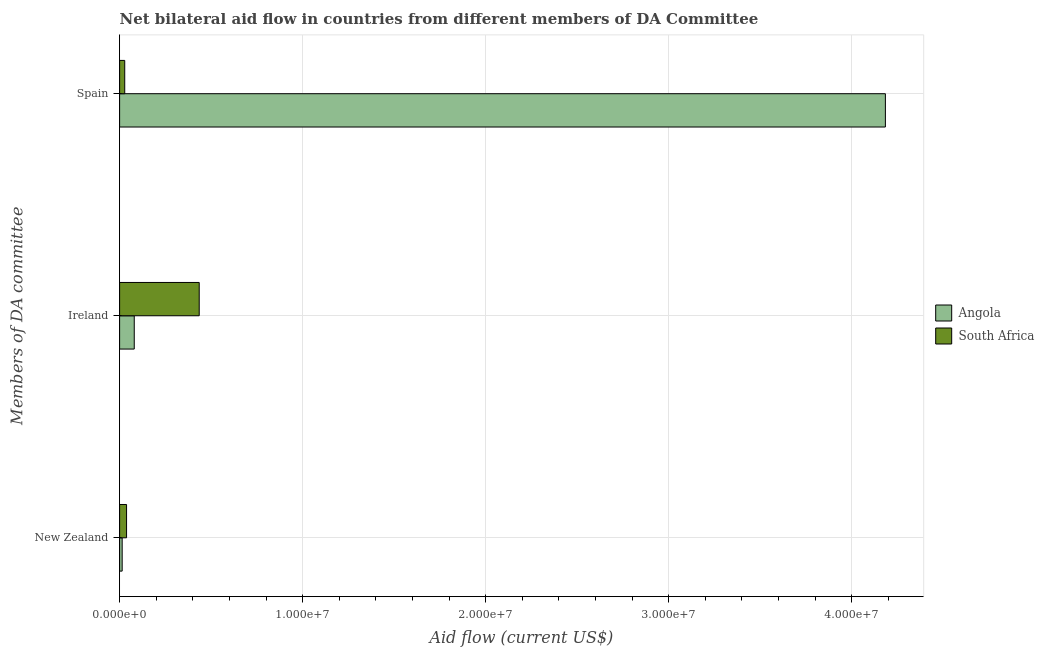How many different coloured bars are there?
Provide a short and direct response. 2. How many groups of bars are there?
Give a very brief answer. 3. Are the number of bars on each tick of the Y-axis equal?
Your response must be concise. Yes. How many bars are there on the 3rd tick from the top?
Provide a short and direct response. 2. What is the label of the 2nd group of bars from the top?
Give a very brief answer. Ireland. What is the amount of aid provided by spain in Angola?
Offer a very short reply. 4.18e+07. Across all countries, what is the maximum amount of aid provided by new zealand?
Offer a terse response. 3.80e+05. Across all countries, what is the minimum amount of aid provided by new zealand?
Keep it short and to the point. 1.40e+05. In which country was the amount of aid provided by ireland maximum?
Give a very brief answer. South Africa. In which country was the amount of aid provided by spain minimum?
Make the answer very short. South Africa. What is the total amount of aid provided by new zealand in the graph?
Make the answer very short. 5.20e+05. What is the difference between the amount of aid provided by spain in South Africa and that in Angola?
Offer a terse response. -4.16e+07. What is the difference between the amount of aid provided by spain in South Africa and the amount of aid provided by ireland in Angola?
Your answer should be compact. -5.20e+05. What is the average amount of aid provided by spain per country?
Your answer should be compact. 2.11e+07. What is the difference between the amount of aid provided by new zealand and amount of aid provided by spain in Angola?
Give a very brief answer. -4.17e+07. In how many countries, is the amount of aid provided by ireland greater than 2000000 US$?
Your answer should be very brief. 1. What is the ratio of the amount of aid provided by new zealand in South Africa to that in Angola?
Your answer should be compact. 2.71. Is the difference between the amount of aid provided by new zealand in Angola and South Africa greater than the difference between the amount of aid provided by ireland in Angola and South Africa?
Provide a succinct answer. Yes. What is the difference between the highest and the second highest amount of aid provided by spain?
Offer a terse response. 4.16e+07. What is the difference between the highest and the lowest amount of aid provided by spain?
Give a very brief answer. 4.16e+07. In how many countries, is the amount of aid provided by new zealand greater than the average amount of aid provided by new zealand taken over all countries?
Keep it short and to the point. 1. Is the sum of the amount of aid provided by ireland in South Africa and Angola greater than the maximum amount of aid provided by spain across all countries?
Give a very brief answer. No. What does the 1st bar from the top in Spain represents?
Provide a short and direct response. South Africa. What does the 2nd bar from the bottom in Ireland represents?
Keep it short and to the point. South Africa. Are all the bars in the graph horizontal?
Your answer should be very brief. Yes. What is the difference between two consecutive major ticks on the X-axis?
Provide a succinct answer. 1.00e+07. How many legend labels are there?
Your answer should be compact. 2. What is the title of the graph?
Your answer should be compact. Net bilateral aid flow in countries from different members of DA Committee. What is the label or title of the Y-axis?
Your answer should be very brief. Members of DA committee. What is the Aid flow (current US$) of Angola in New Zealand?
Your answer should be compact. 1.40e+05. What is the Aid flow (current US$) in South Africa in Ireland?
Offer a terse response. 4.35e+06. What is the Aid flow (current US$) in Angola in Spain?
Keep it short and to the point. 4.18e+07. What is the Aid flow (current US$) in South Africa in Spain?
Your response must be concise. 2.80e+05. Across all Members of DA committee, what is the maximum Aid flow (current US$) of Angola?
Provide a succinct answer. 4.18e+07. Across all Members of DA committee, what is the maximum Aid flow (current US$) of South Africa?
Your answer should be very brief. 4.35e+06. Across all Members of DA committee, what is the minimum Aid flow (current US$) in Angola?
Your answer should be very brief. 1.40e+05. Across all Members of DA committee, what is the minimum Aid flow (current US$) of South Africa?
Your response must be concise. 2.80e+05. What is the total Aid flow (current US$) of Angola in the graph?
Your answer should be compact. 4.28e+07. What is the total Aid flow (current US$) in South Africa in the graph?
Keep it short and to the point. 5.01e+06. What is the difference between the Aid flow (current US$) of Angola in New Zealand and that in Ireland?
Offer a very short reply. -6.60e+05. What is the difference between the Aid flow (current US$) in South Africa in New Zealand and that in Ireland?
Your answer should be very brief. -3.97e+06. What is the difference between the Aid flow (current US$) in Angola in New Zealand and that in Spain?
Make the answer very short. -4.17e+07. What is the difference between the Aid flow (current US$) in South Africa in New Zealand and that in Spain?
Give a very brief answer. 1.00e+05. What is the difference between the Aid flow (current US$) of Angola in Ireland and that in Spain?
Keep it short and to the point. -4.10e+07. What is the difference between the Aid flow (current US$) in South Africa in Ireland and that in Spain?
Offer a terse response. 4.07e+06. What is the difference between the Aid flow (current US$) of Angola in New Zealand and the Aid flow (current US$) of South Africa in Ireland?
Ensure brevity in your answer.  -4.21e+06. What is the difference between the Aid flow (current US$) in Angola in Ireland and the Aid flow (current US$) in South Africa in Spain?
Offer a terse response. 5.20e+05. What is the average Aid flow (current US$) in Angola per Members of DA committee?
Your response must be concise. 1.43e+07. What is the average Aid flow (current US$) of South Africa per Members of DA committee?
Your answer should be very brief. 1.67e+06. What is the difference between the Aid flow (current US$) of Angola and Aid flow (current US$) of South Africa in New Zealand?
Your answer should be very brief. -2.40e+05. What is the difference between the Aid flow (current US$) of Angola and Aid flow (current US$) of South Africa in Ireland?
Ensure brevity in your answer.  -3.55e+06. What is the difference between the Aid flow (current US$) in Angola and Aid flow (current US$) in South Africa in Spain?
Provide a short and direct response. 4.16e+07. What is the ratio of the Aid flow (current US$) in Angola in New Zealand to that in Ireland?
Your answer should be very brief. 0.17. What is the ratio of the Aid flow (current US$) of South Africa in New Zealand to that in Ireland?
Ensure brevity in your answer.  0.09. What is the ratio of the Aid flow (current US$) of Angola in New Zealand to that in Spain?
Make the answer very short. 0. What is the ratio of the Aid flow (current US$) in South Africa in New Zealand to that in Spain?
Give a very brief answer. 1.36. What is the ratio of the Aid flow (current US$) of Angola in Ireland to that in Spain?
Offer a very short reply. 0.02. What is the ratio of the Aid flow (current US$) in South Africa in Ireland to that in Spain?
Keep it short and to the point. 15.54. What is the difference between the highest and the second highest Aid flow (current US$) of Angola?
Keep it short and to the point. 4.10e+07. What is the difference between the highest and the second highest Aid flow (current US$) in South Africa?
Offer a very short reply. 3.97e+06. What is the difference between the highest and the lowest Aid flow (current US$) of Angola?
Keep it short and to the point. 4.17e+07. What is the difference between the highest and the lowest Aid flow (current US$) of South Africa?
Keep it short and to the point. 4.07e+06. 